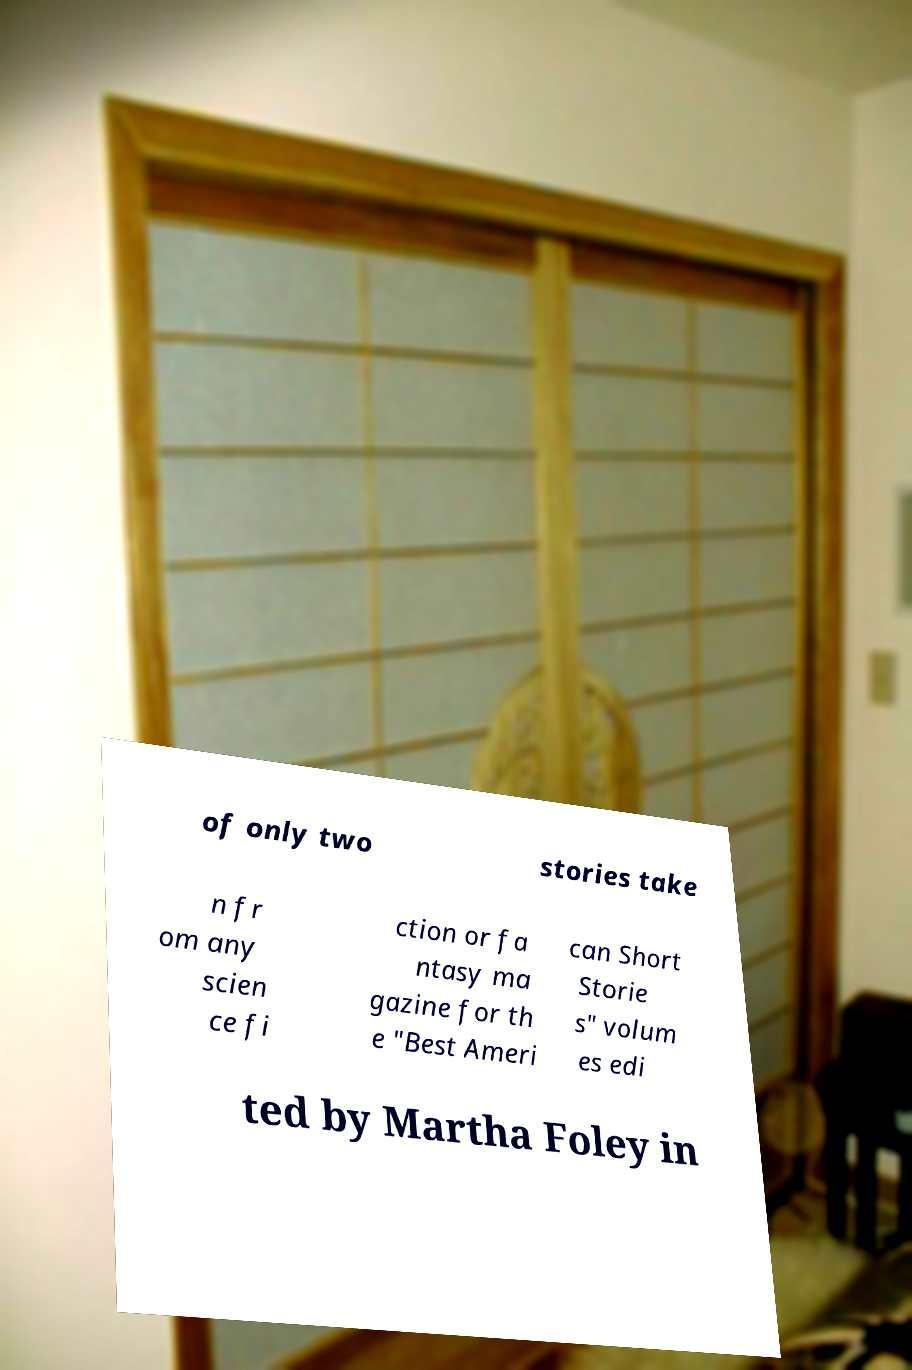Can you read and provide the text displayed in the image?This photo seems to have some interesting text. Can you extract and type it out for me? of only two stories take n fr om any scien ce fi ction or fa ntasy ma gazine for th e "Best Ameri can Short Storie s" volum es edi ted by Martha Foley in 